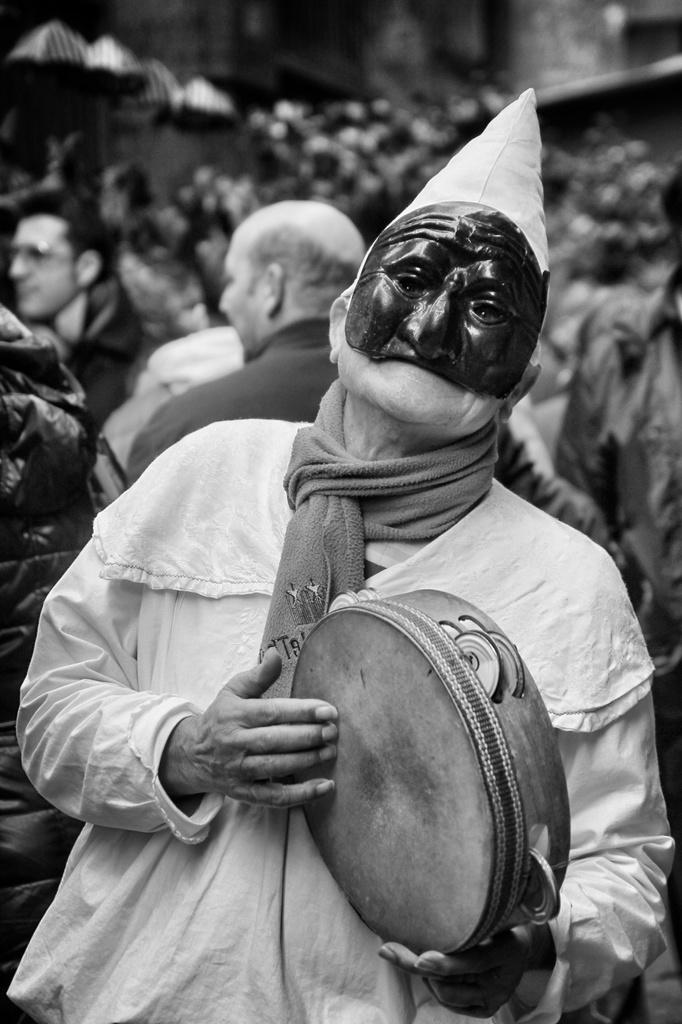What is the person in the image doing? The person is playing a dayereh. Can you describe the appearance of the person in the image? The person is wearing a mask. What can be seen in the background of the image? There are people and other objects in the background of the image. How would you describe the top part of the image? The top part of the image is blurred. What type of straw is being used to make selections in the image? There is no straw present in the image, nor is there any indication of a selection process. 